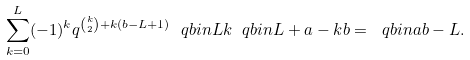<formula> <loc_0><loc_0><loc_500><loc_500>\sum _ { k = 0 } ^ { L } ( - 1 ) ^ { k } q ^ { \binom { k } { 2 } + k ( b - L + 1 ) } \ q b i n { L } { k } \ q b i n { L + a - k } { b } = \ q b i n { a } { b - L } .</formula> 